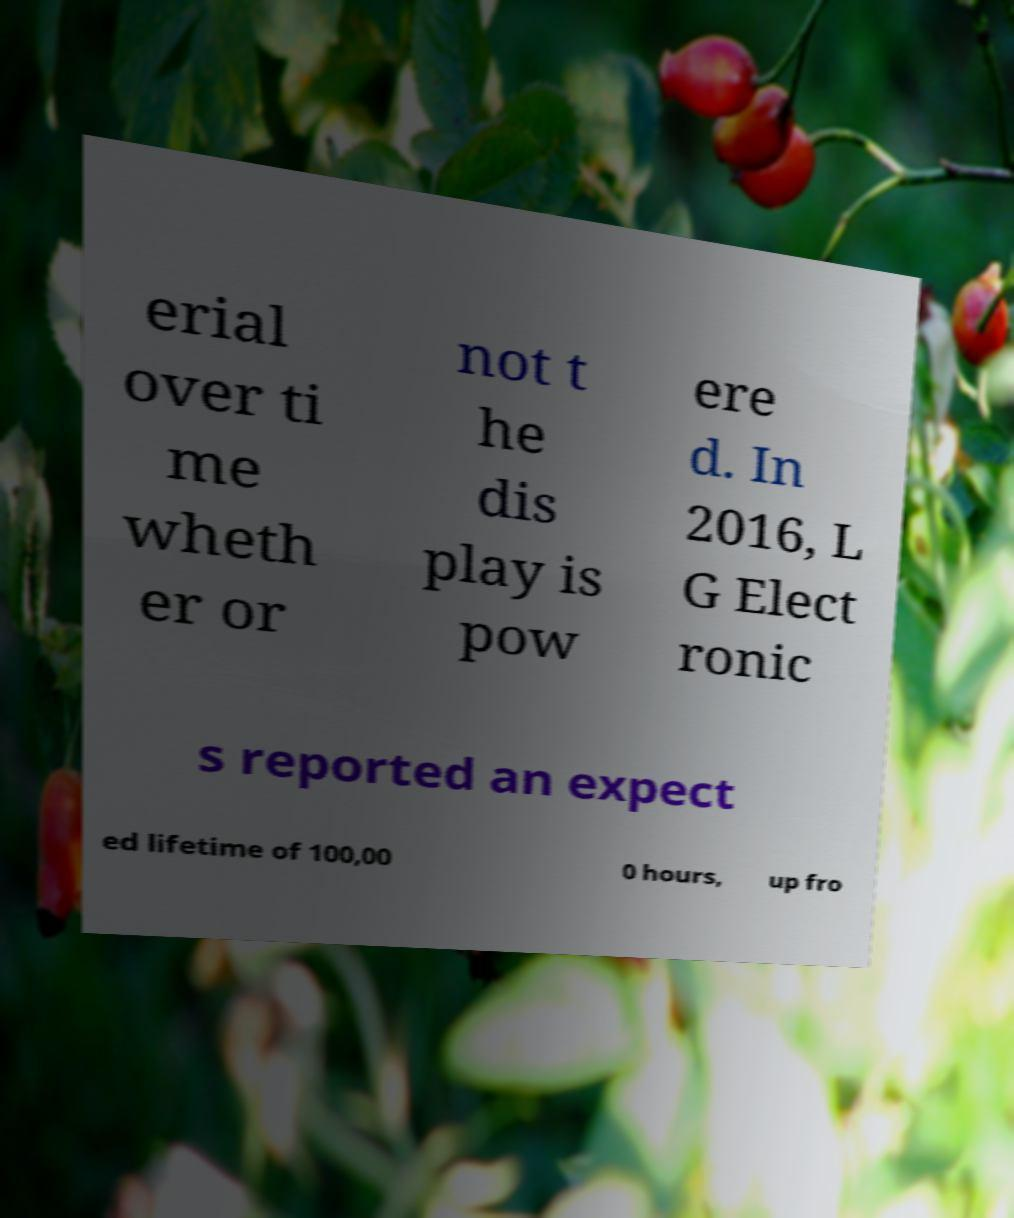Please identify and transcribe the text found in this image. erial over ti me wheth er or not t he dis play is pow ere d. In 2016, L G Elect ronic s reported an expect ed lifetime of 100,00 0 hours, up fro 